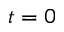Convert formula to latex. <formula><loc_0><loc_0><loc_500><loc_500>t = 0</formula> 